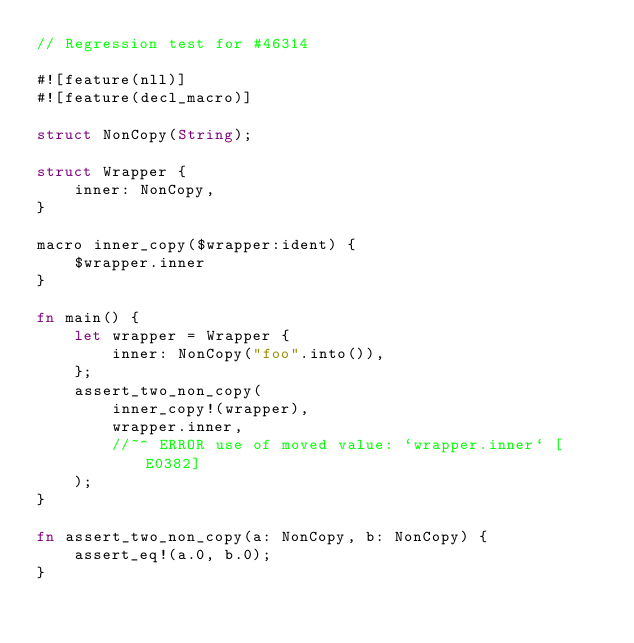Convert code to text. <code><loc_0><loc_0><loc_500><loc_500><_Rust_>// Regression test for #46314

#![feature(nll)]
#![feature(decl_macro)]

struct NonCopy(String);

struct Wrapper {
    inner: NonCopy,
}

macro inner_copy($wrapper:ident) {
    $wrapper.inner
}

fn main() {
    let wrapper = Wrapper {
        inner: NonCopy("foo".into()),
    };
    assert_two_non_copy(
        inner_copy!(wrapper),
        wrapper.inner,
        //~^ ERROR use of moved value: `wrapper.inner` [E0382]
    );
}

fn assert_two_non_copy(a: NonCopy, b: NonCopy) {
    assert_eq!(a.0, b.0);
}
</code> 